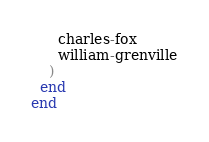<code> <loc_0><loc_0><loc_500><loc_500><_Ruby_>      charles-fox
      william-grenville
    )
  end
end
</code> 